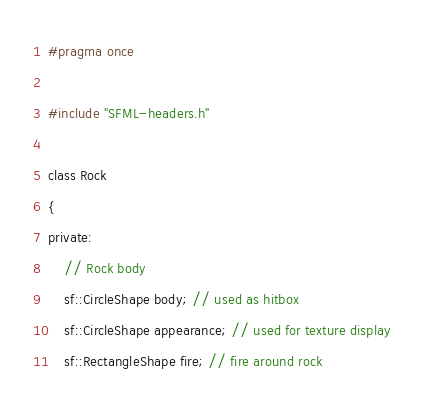<code> <loc_0><loc_0><loc_500><loc_500><_C_>#pragma once

#include "SFML-headers.h"

class Rock
{
private:
	// Rock body
	sf::CircleShape body; // used as hitbox
	sf::CircleShape appearance; // used for texture display
	sf::RectangleShape fire; // fire around rock
</code> 